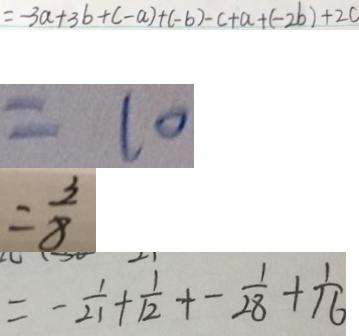<formula> <loc_0><loc_0><loc_500><loc_500>= - 3 a + 3 b + ( - a ) + ( - b ) - c + a + ( - 2 b ) + 2 c 
 = 1 0 
 = \frac { 3 } { 8 } 
 = - \frac { 1 } { 2 1 } + \frac { 1 } { 1 2 } + - \frac { 1 } { 2 8 } + \frac { 1 } { 1 6 }</formula> 